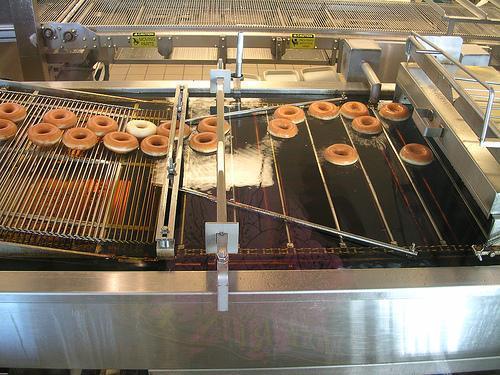How many fryers are there?
Give a very brief answer. 1. 